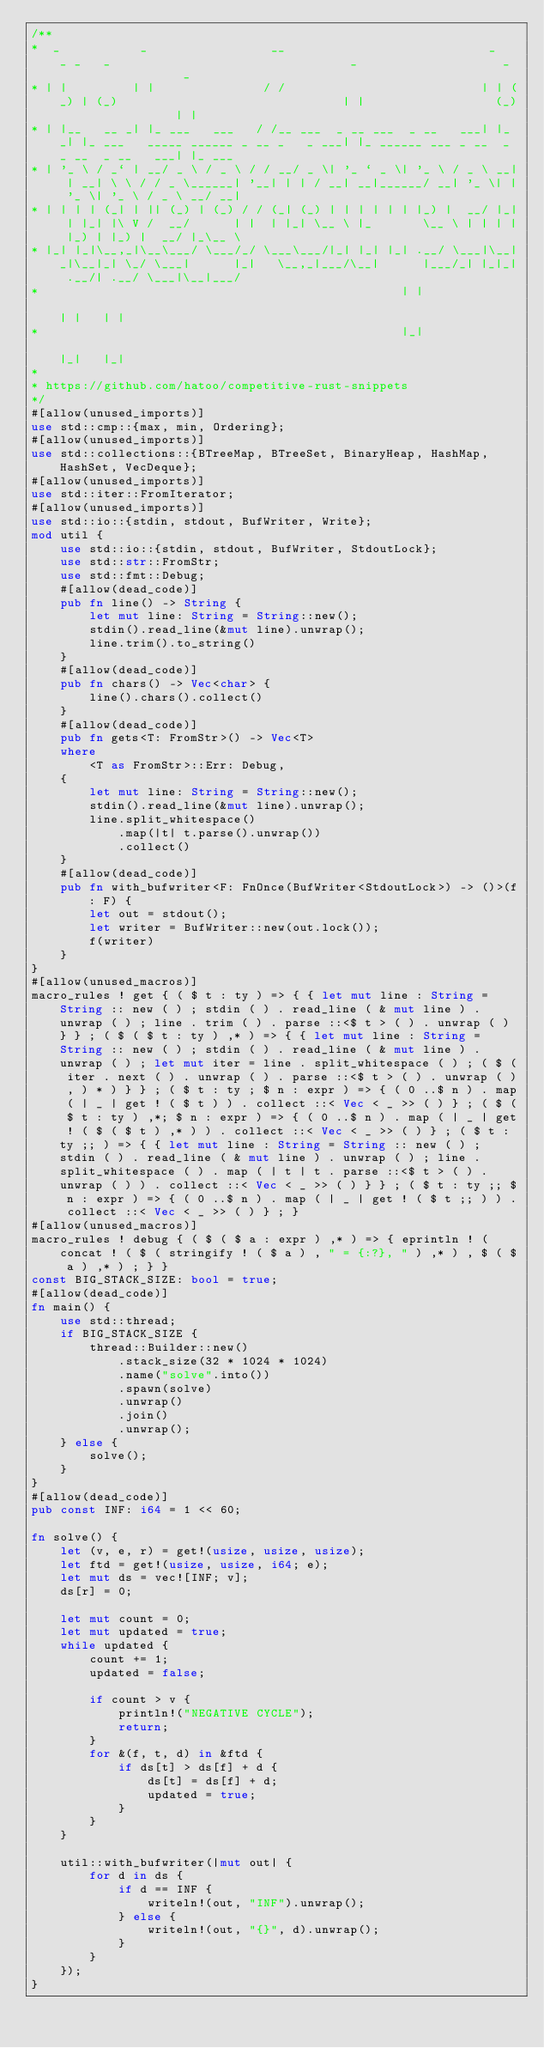<code> <loc_0><loc_0><loc_500><loc_500><_Rust_>/**
*  _           _                 __                            _   _ _   _                                 _                    _                  _
* | |         | |               / /                           | | (_) | (_)                               | |                  (_)                | |
* | |__   __ _| |_ ___   ___   / /__ ___  _ __ ___  _ __   ___| |_ _| |_ ___   _____ ______ _ __ _   _ ___| |_ ______ ___ _ __  _ _ __  _ __   ___| |_ ___
* | '_ \ / _` | __/ _ \ / _ \ / / __/ _ \| '_ ` _ \| '_ \ / _ \ __| | __| \ \ / / _ \______| '__| | | / __| __|______/ __| '_ \| | '_ \| '_ \ / _ \ __/ __|
* | | | | (_| | || (_) | (_) / / (_| (_) | | | | | | |_) |  __/ |_| | |_| |\ V /  __/      | |  | |_| \__ \ |_       \__ \ | | | | |_) | |_) |  __/ |_\__ \
* |_| |_|\__,_|\__\___/ \___/_/ \___\___/|_| |_| |_| .__/ \___|\__|_|\__|_| \_/ \___|      |_|   \__,_|___/\__|      |___/_| |_|_| .__/| .__/ \___|\__|___/
*                                                  | |                                                                           | |   | |
*                                                  |_|                                                                           |_|   |_|
*
* https://github.com/hatoo/competitive-rust-snippets
*/
#[allow(unused_imports)]
use std::cmp::{max, min, Ordering};
#[allow(unused_imports)]
use std::collections::{BTreeMap, BTreeSet, BinaryHeap, HashMap, HashSet, VecDeque};
#[allow(unused_imports)]
use std::iter::FromIterator;
#[allow(unused_imports)]
use std::io::{stdin, stdout, BufWriter, Write};
mod util {
    use std::io::{stdin, stdout, BufWriter, StdoutLock};
    use std::str::FromStr;
    use std::fmt::Debug;
    #[allow(dead_code)]
    pub fn line() -> String {
        let mut line: String = String::new();
        stdin().read_line(&mut line).unwrap();
        line.trim().to_string()
    }
    #[allow(dead_code)]
    pub fn chars() -> Vec<char> {
        line().chars().collect()
    }
    #[allow(dead_code)]
    pub fn gets<T: FromStr>() -> Vec<T>
    where
        <T as FromStr>::Err: Debug,
    {
        let mut line: String = String::new();
        stdin().read_line(&mut line).unwrap();
        line.split_whitespace()
            .map(|t| t.parse().unwrap())
            .collect()
    }
    #[allow(dead_code)]
    pub fn with_bufwriter<F: FnOnce(BufWriter<StdoutLock>) -> ()>(f: F) {
        let out = stdout();
        let writer = BufWriter::new(out.lock());
        f(writer)
    }
}
#[allow(unused_macros)]
macro_rules ! get { ( $ t : ty ) => { { let mut line : String = String :: new ( ) ; stdin ( ) . read_line ( & mut line ) . unwrap ( ) ; line . trim ( ) . parse ::<$ t > ( ) . unwrap ( ) } } ; ( $ ( $ t : ty ) ,* ) => { { let mut line : String = String :: new ( ) ; stdin ( ) . read_line ( & mut line ) . unwrap ( ) ; let mut iter = line . split_whitespace ( ) ; ( $ ( iter . next ( ) . unwrap ( ) . parse ::<$ t > ( ) . unwrap ( ) , ) * ) } } ; ( $ t : ty ; $ n : expr ) => { ( 0 ..$ n ) . map ( | _ | get ! ( $ t ) ) . collect ::< Vec < _ >> ( ) } ; ( $ ( $ t : ty ) ,*; $ n : expr ) => { ( 0 ..$ n ) . map ( | _ | get ! ( $ ( $ t ) ,* ) ) . collect ::< Vec < _ >> ( ) } ; ( $ t : ty ;; ) => { { let mut line : String = String :: new ( ) ; stdin ( ) . read_line ( & mut line ) . unwrap ( ) ; line . split_whitespace ( ) . map ( | t | t . parse ::<$ t > ( ) . unwrap ( ) ) . collect ::< Vec < _ >> ( ) } } ; ( $ t : ty ;; $ n : expr ) => { ( 0 ..$ n ) . map ( | _ | get ! ( $ t ;; ) ) . collect ::< Vec < _ >> ( ) } ; }
#[allow(unused_macros)]
macro_rules ! debug { ( $ ( $ a : expr ) ,* ) => { eprintln ! ( concat ! ( $ ( stringify ! ( $ a ) , " = {:?}, " ) ,* ) , $ ( $ a ) ,* ) ; } }
const BIG_STACK_SIZE: bool = true;
#[allow(dead_code)]
fn main() {
    use std::thread;
    if BIG_STACK_SIZE {
        thread::Builder::new()
            .stack_size(32 * 1024 * 1024)
            .name("solve".into())
            .spawn(solve)
            .unwrap()
            .join()
            .unwrap();
    } else {
        solve();
    }
}
#[allow(dead_code)]
pub const INF: i64 = 1 << 60;

fn solve() {
    let (v, e, r) = get!(usize, usize, usize);
    let ftd = get!(usize, usize, i64; e);
    let mut ds = vec![INF; v];
    ds[r] = 0;

    let mut count = 0;
    let mut updated = true;
    while updated {
        count += 1;
        updated = false;

        if count > v {
            println!("NEGATIVE CYCLE");
            return;
        }
        for &(f, t, d) in &ftd {
            if ds[t] > ds[f] + d {
                ds[t] = ds[f] + d;
                updated = true;
            }
        }
    }

    util::with_bufwriter(|mut out| {
        for d in ds {
            if d == INF {
                writeln!(out, "INF").unwrap();
            } else {
                writeln!(out, "{}", d).unwrap();
            }
        }
    });
}

</code> 